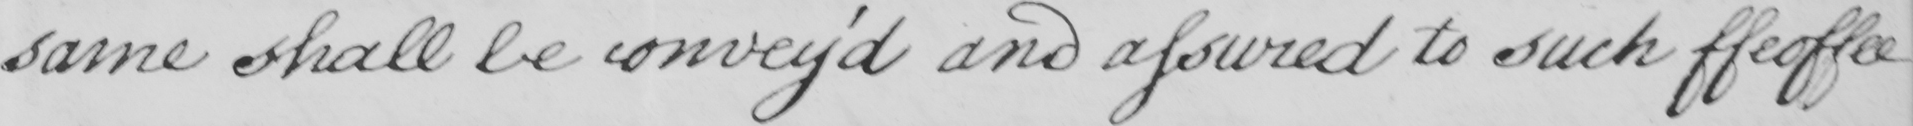Please provide the text content of this handwritten line. same shall be convey ' d and assured to such ffeoffee 